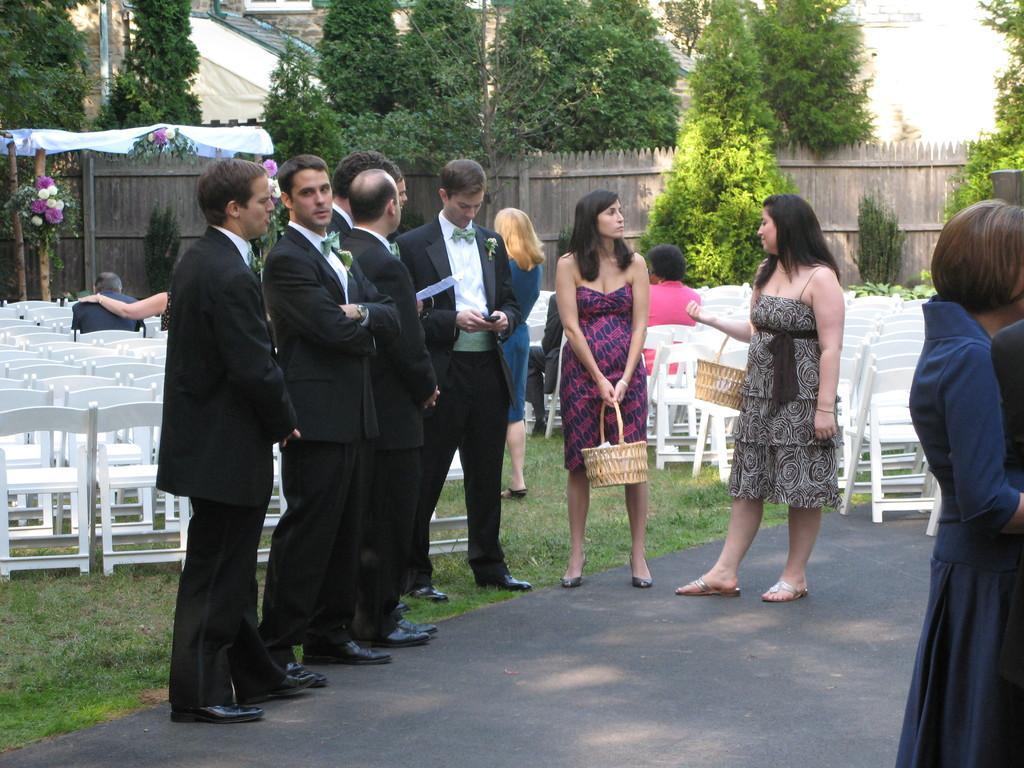In one or two sentences, can you explain what this image depicts? Here we can see few persons are standing on the road. This is grass and there are chairs. Here we can see plants, trees, flowers, and a fence. 